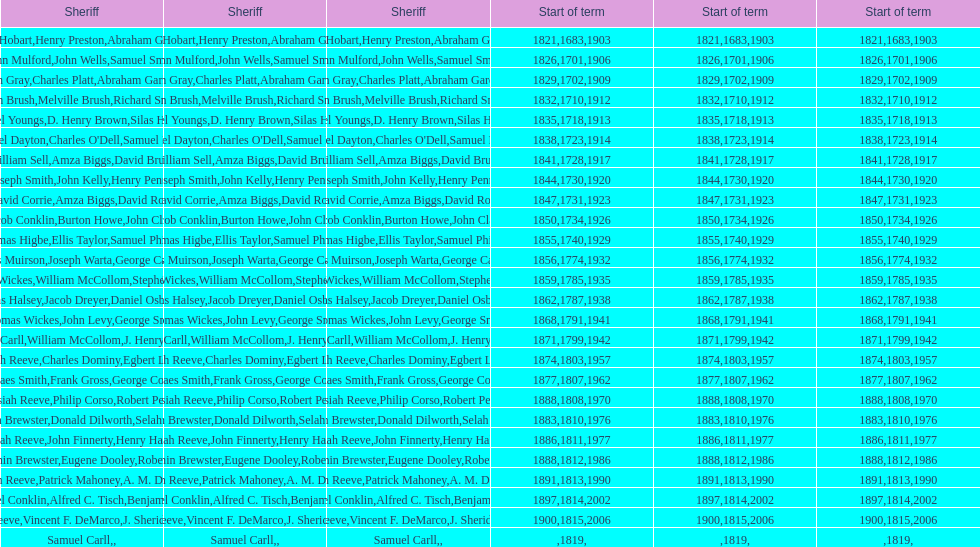When did benjamin brewster serve his second term? 1812. 